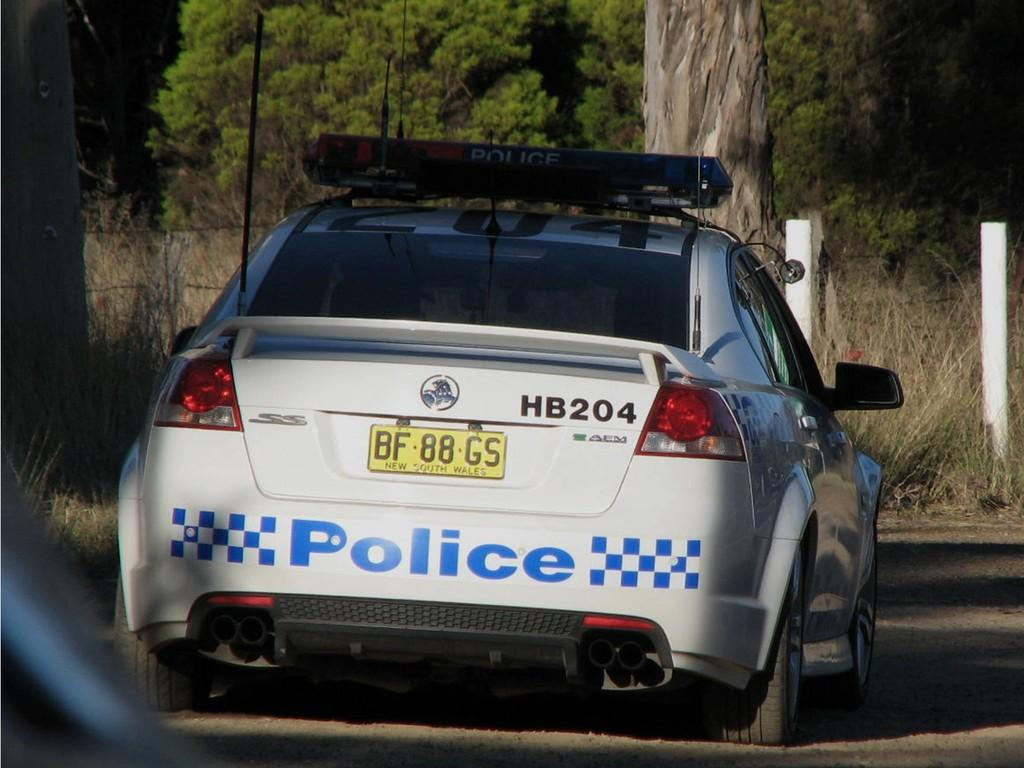<image>
Relay a brief, clear account of the picture shown. White Police car on the side of the road 